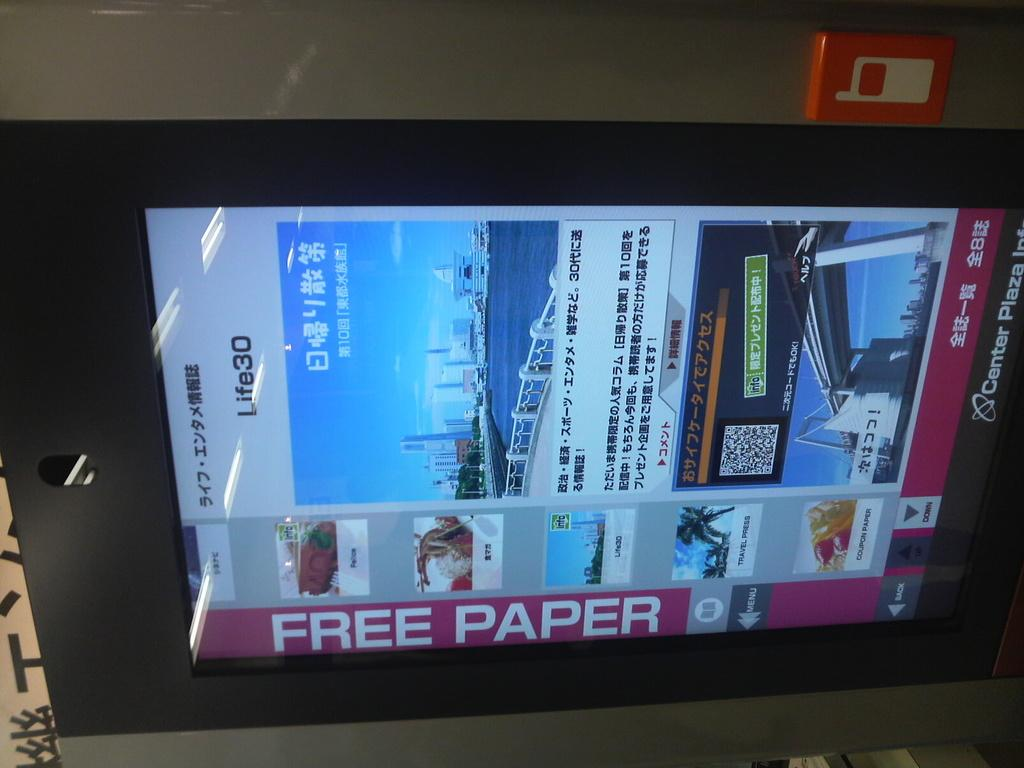<image>
Render a clear and concise summary of the photo. a screen for the Center Plaza Inc., that is advertizing for free paper. 